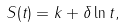<formula> <loc_0><loc_0><loc_500><loc_500>S ( t ) = k + \delta \ln t ,</formula> 